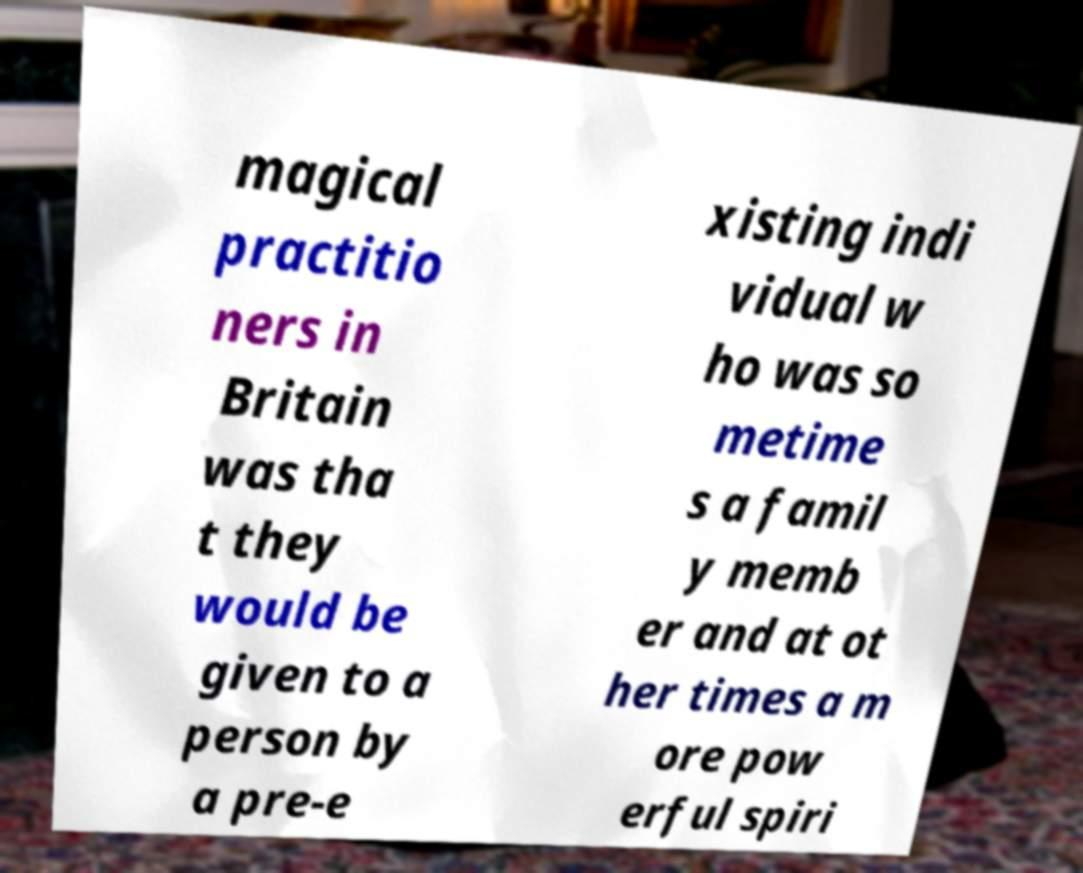Can you accurately transcribe the text from the provided image for me? magical practitio ners in Britain was tha t they would be given to a person by a pre-e xisting indi vidual w ho was so metime s a famil y memb er and at ot her times a m ore pow erful spiri 